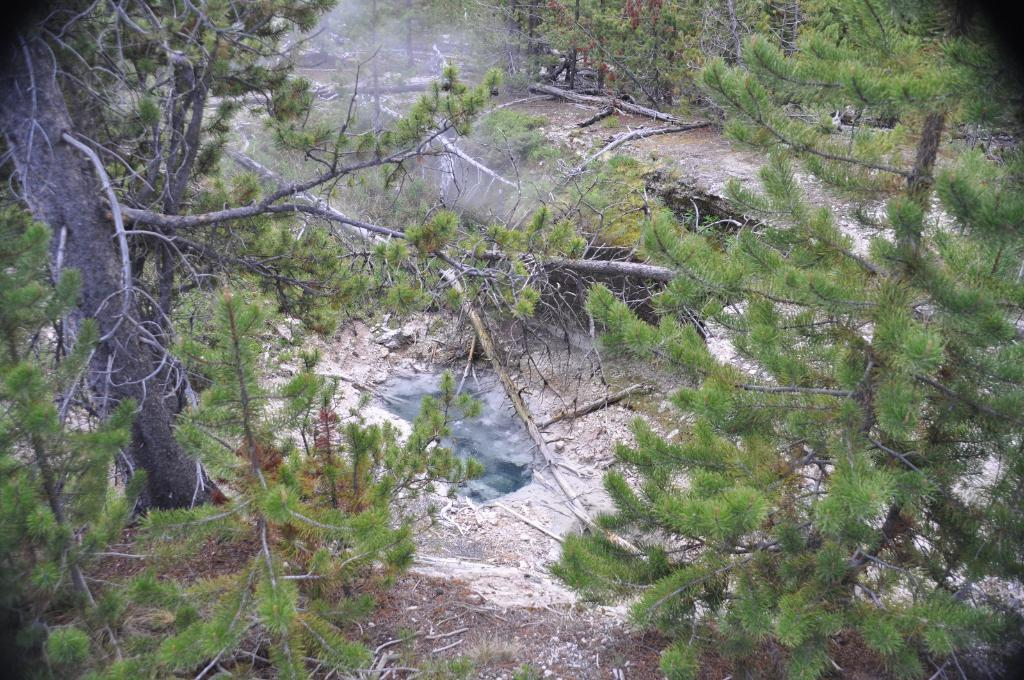What type of vegetation can be seen in the image? There is a group of trees in the image. What else can be found among the trees in the image? There are dried branches in the image. What type of train can be seen passing through the trees in the image? There is no train present in the image; it only features a group of trees and dried branches. 